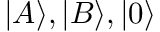Convert formula to latex. <formula><loc_0><loc_0><loc_500><loc_500>| A \rangle , | B \rangle , | 0 \rangle</formula> 